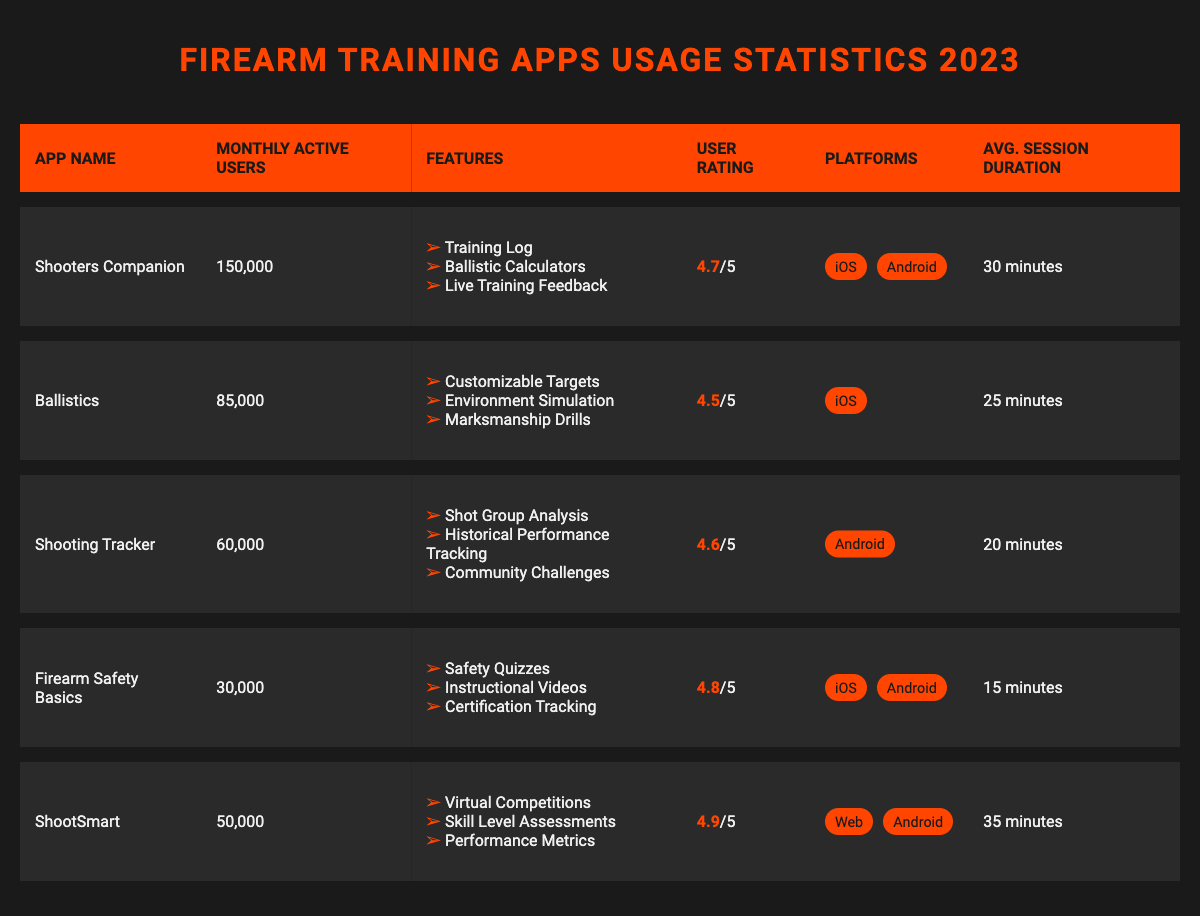What is the user rating of the app "Shooters Companion"? The user rating for "Shooters Companion" is directly provided in the table under the User Rating column, which shows a rating of 4.7.
Answer: 4.7 How many monthly active users does the "Ballistics" app have? The "Ballistics" app's monthly active users are specifically listed in the table as 85,000.
Answer: 85,000 Which app has the highest average session duration? To find this, we compare the average session durations of all apps in the table. "ShootSmart" has the highest at 35 minutes.
Answer: ShootSmart Are there any apps available on both iOS and Android platforms? By checking the Platforms column for the apps, both "Shooters Companion" and "Firearm Safety Basics" are listed as available on iOS and Android. Therefore, the answer is yes.
Answer: Yes What is the total number of monthly active users for all apps combined? We sum the monthly active users for each app: 150,000 + 85,000 + 60,000 + 30,000 + 50,000 = 375,000.
Answer: 375,000 Which app has the lowest user rating? We need to look at the user ratings in the table. "Ballistics" has a user rating of 4.5, which is the lowest among all listed ratings.
Answer: Ballistics What is the average user rating for all apps? First, we add together all the user ratings: 4.7 + 4.5 + 4.6 + 4.8 + 4.9 = 24.5. Then we divide by the number of apps (5) to find the average: 24.5 / 5 = 4.9.
Answer: 4.9 How many features does "Shooting Tracker" have? "Shooting Tracker" has three features listed in the Features column: Shot Group Analysis, Historical Performance Tracking, and Community Challenges.
Answer: 3 Is the app "Firearm Safety Basics" rated higher than 4.6? Checking the user rating listed for "Firearm Safety Basics," which is 4.8, we confirm it is indeed higher than 4.6.
Answer: Yes Which app has fewer than 40,000 monthly active users? We can see that "Firearm Safety Basics" with 30,000 users is the only app listed with fewer than 40,000 monthly active users.
Answer: Firearm Safety Basics 